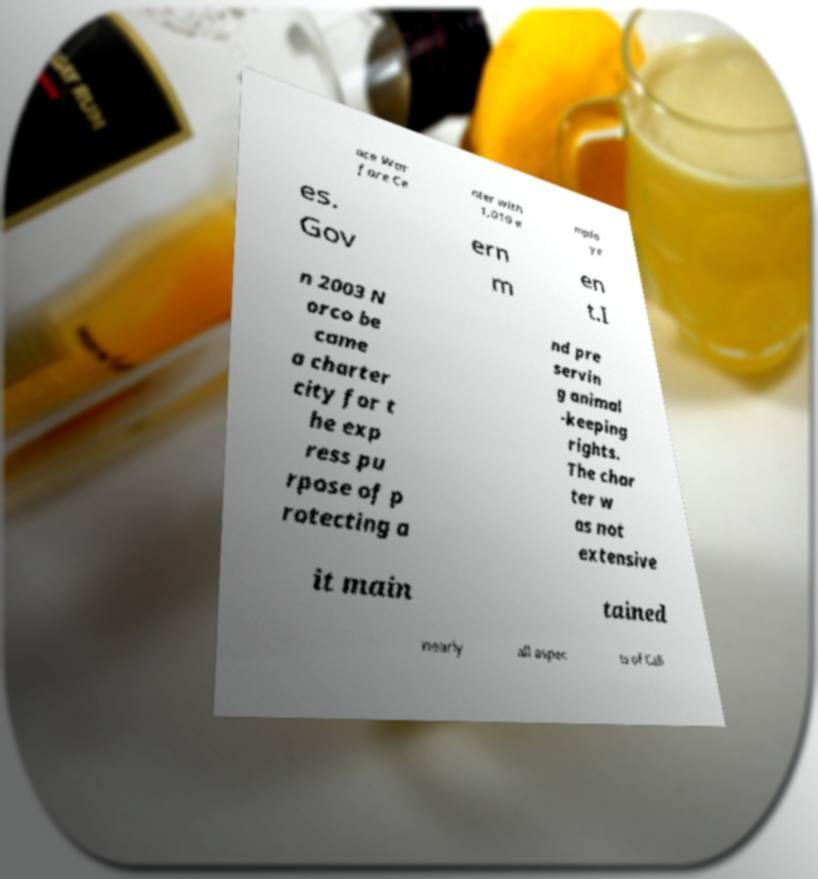There's text embedded in this image that I need extracted. Can you transcribe it verbatim? ace War fare Ce nter with 1,010 e mplo ye es. Gov ern m en t.I n 2003 N orco be came a charter city for t he exp ress pu rpose of p rotecting a nd pre servin g animal -keeping rights. The char ter w as not extensive it main tained nearly all aspec ts of Cali 